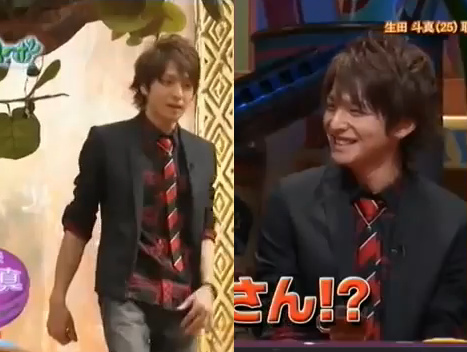What might be the significance of the setting? The setting seems to be significant for creating a formal and engaging environment. It could be a television studio designed to make the guest feel important and the event feel grand. The elements in the image, like the decorations and the background, are all chosen meticulously to enhance the experience of both the participants and the viewers. 